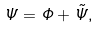<formula> <loc_0><loc_0><loc_500><loc_500>\Psi = \Phi + \tilde { \Psi } ,</formula> 